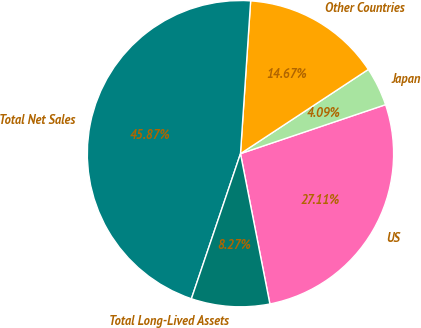Convert chart. <chart><loc_0><loc_0><loc_500><loc_500><pie_chart><fcel>US<fcel>Japan<fcel>Other Countries<fcel>Total Net Sales<fcel>Total Long-Lived Assets<nl><fcel>27.11%<fcel>4.09%<fcel>14.67%<fcel>45.87%<fcel>8.27%<nl></chart> 